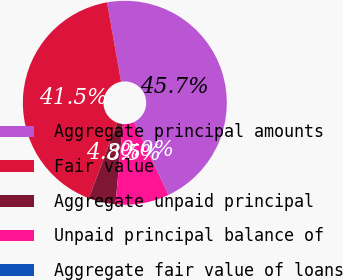Convert chart to OTSL. <chart><loc_0><loc_0><loc_500><loc_500><pie_chart><fcel>Aggregate principal amounts<fcel>Fair value<fcel>Aggregate unpaid principal<fcel>Unpaid principal balance of<fcel>Aggregate fair value of loans<nl><fcel>45.72%<fcel>41.47%<fcel>4.27%<fcel>8.51%<fcel>0.03%<nl></chart> 